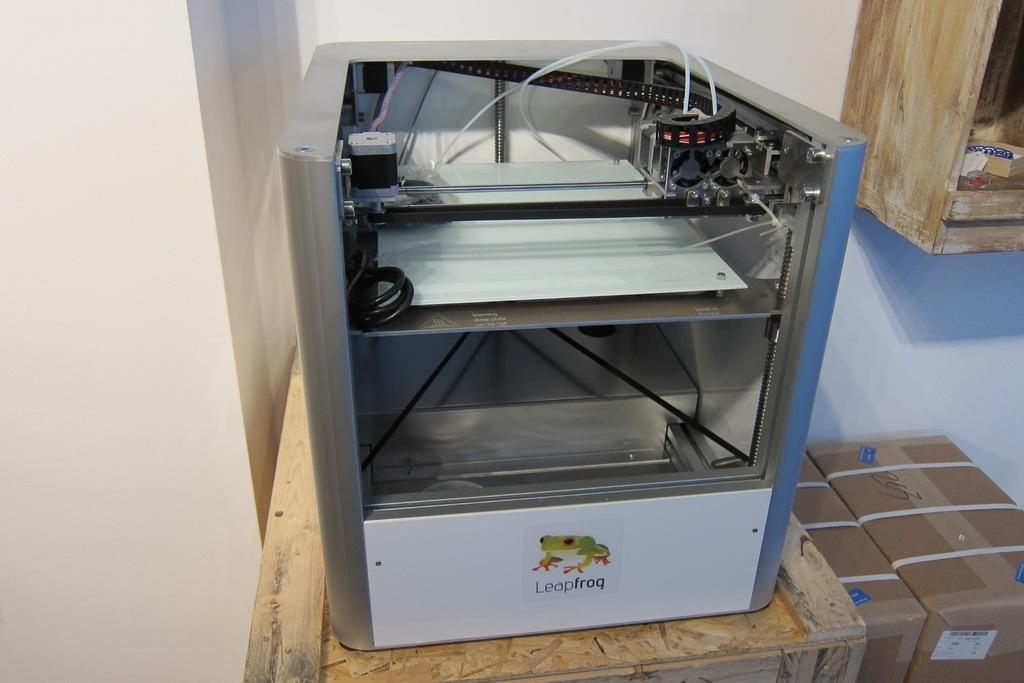Provide a one-sentence caption for the provided image. a large machine with a frog on it and the text 'leapfrog'. 